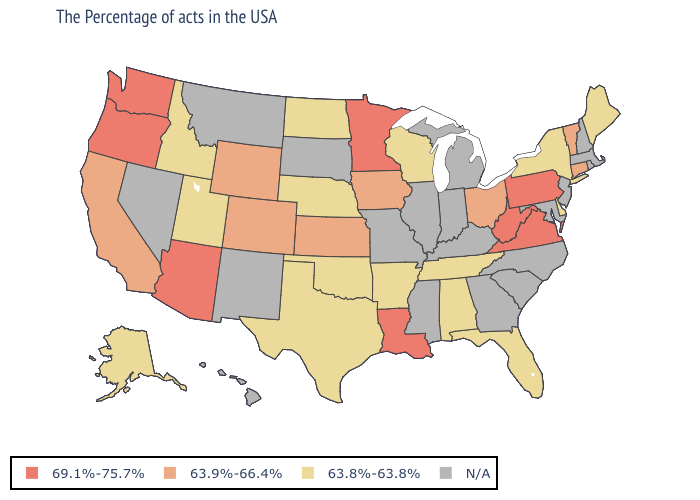Name the states that have a value in the range 63.9%-66.4%?
Give a very brief answer. Vermont, Connecticut, Ohio, Iowa, Kansas, Wyoming, Colorado, California. Among the states that border New Mexico , which have the lowest value?
Write a very short answer. Oklahoma, Texas, Utah. What is the value of Alaska?
Be succinct. 63.8%-63.8%. Name the states that have a value in the range 63.9%-66.4%?
Give a very brief answer. Vermont, Connecticut, Ohio, Iowa, Kansas, Wyoming, Colorado, California. Name the states that have a value in the range 69.1%-75.7%?
Concise answer only. Pennsylvania, Virginia, West Virginia, Louisiana, Minnesota, Arizona, Washington, Oregon. What is the lowest value in the USA?
Quick response, please. 63.8%-63.8%. What is the value of New York?
Keep it brief. 63.8%-63.8%. Which states have the lowest value in the USA?
Concise answer only. Maine, New York, Delaware, Florida, Alabama, Tennessee, Wisconsin, Arkansas, Nebraska, Oklahoma, Texas, North Dakota, Utah, Idaho, Alaska. Name the states that have a value in the range N/A?
Concise answer only. Massachusetts, Rhode Island, New Hampshire, New Jersey, Maryland, North Carolina, South Carolina, Georgia, Michigan, Kentucky, Indiana, Illinois, Mississippi, Missouri, South Dakota, New Mexico, Montana, Nevada, Hawaii. Does the map have missing data?
Write a very short answer. Yes. Is the legend a continuous bar?
Short answer required. No. Does North Dakota have the highest value in the MidWest?
Concise answer only. No. What is the value of Nebraska?
Concise answer only. 63.8%-63.8%. 